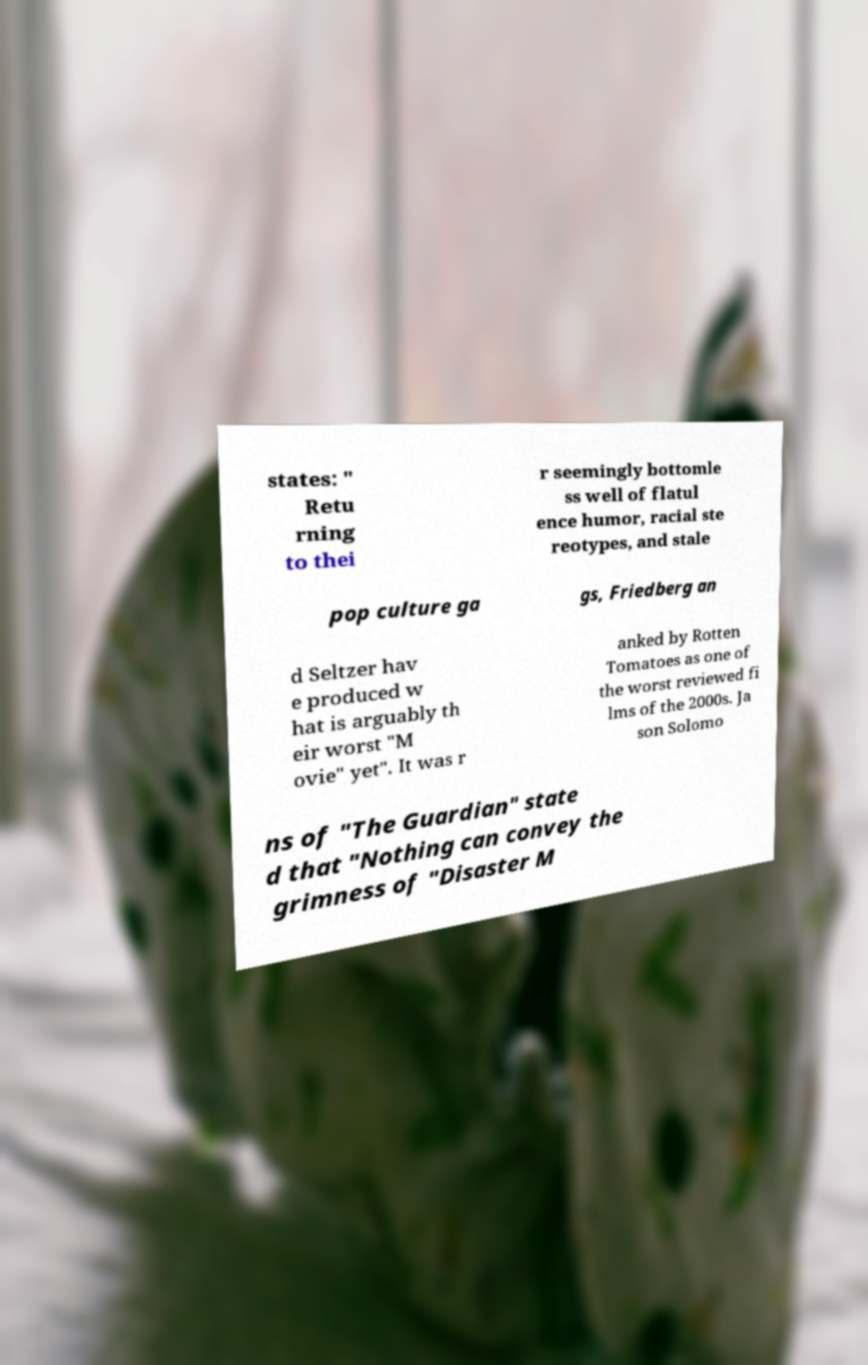What messages or text are displayed in this image? I need them in a readable, typed format. states: " Retu rning to thei r seemingly bottomle ss well of flatul ence humor, racial ste reotypes, and stale pop culture ga gs, Friedberg an d Seltzer hav e produced w hat is arguably th eir worst "M ovie" yet". It was r anked by Rotten Tomatoes as one of the worst reviewed fi lms of the 2000s. Ja son Solomo ns of "The Guardian" state d that "Nothing can convey the grimness of "Disaster M 